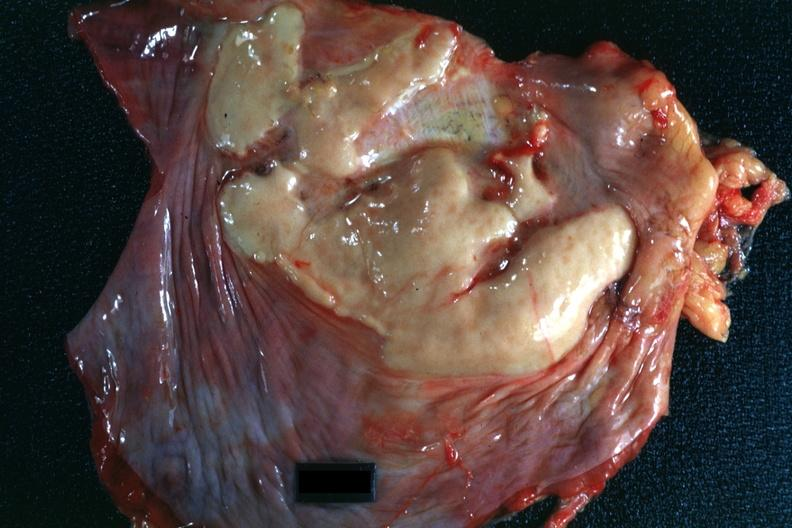does this image show plaque lesion of mesothelioma?
Answer the question using a single word or phrase. Yes 